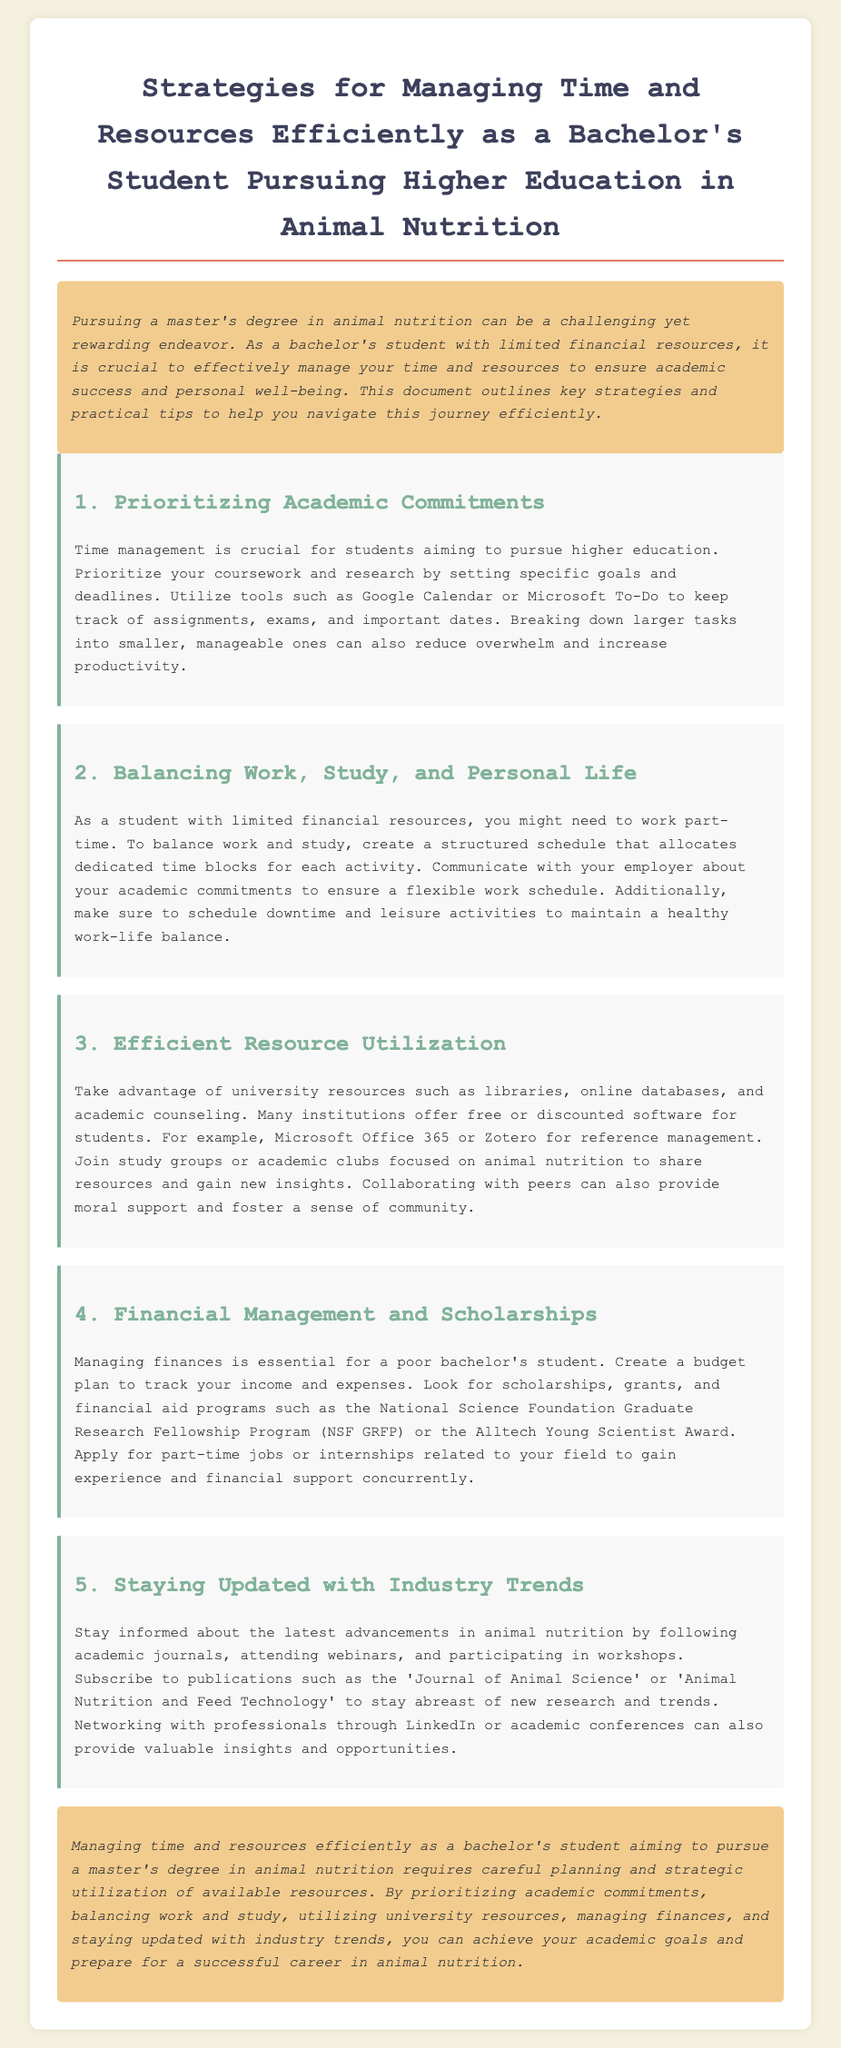what is the title of the document? The title of the document is provided in the header section and summarizes the content it covers.
Answer: Strategies for Managing Time and Resources Efficiently as a Bachelor's Student Pursuing Higher Education in Animal Nutrition how many main strategy sections are included? The document outlines five main strategy sections to tackle time and resource management.
Answer: 5 what tool is suggested for keeping track of assignments? The document specifically suggests utilizing tools to help manage time and tasks for academic success.
Answer: Google Calendar what is one way to balance work and study mentioned? The document emphasizes structuring a schedule to help manage different commitments effectively.
Answer: Structured schedule which scholarship is mentioned in the financial management section? The document provides examples of specific scholarships available to support students financially.
Answer: National Science Foundation Graduate Research Fellowship Program what publication is recommended for staying updated with industry trends? The document lists specific publications to follow for the latest information in the field of animal nutrition.
Answer: Journal of Animal Science what is the main focus of the introduction paragraph? The introduction provides a summary of the challenges and importance of time and resource management for students.
Answer: Importance of managing time and resources what is a benefit of joining study groups according to the document? The document discusses the advantages of collaborative learning environments and community involvement.
Answer: Moral support 